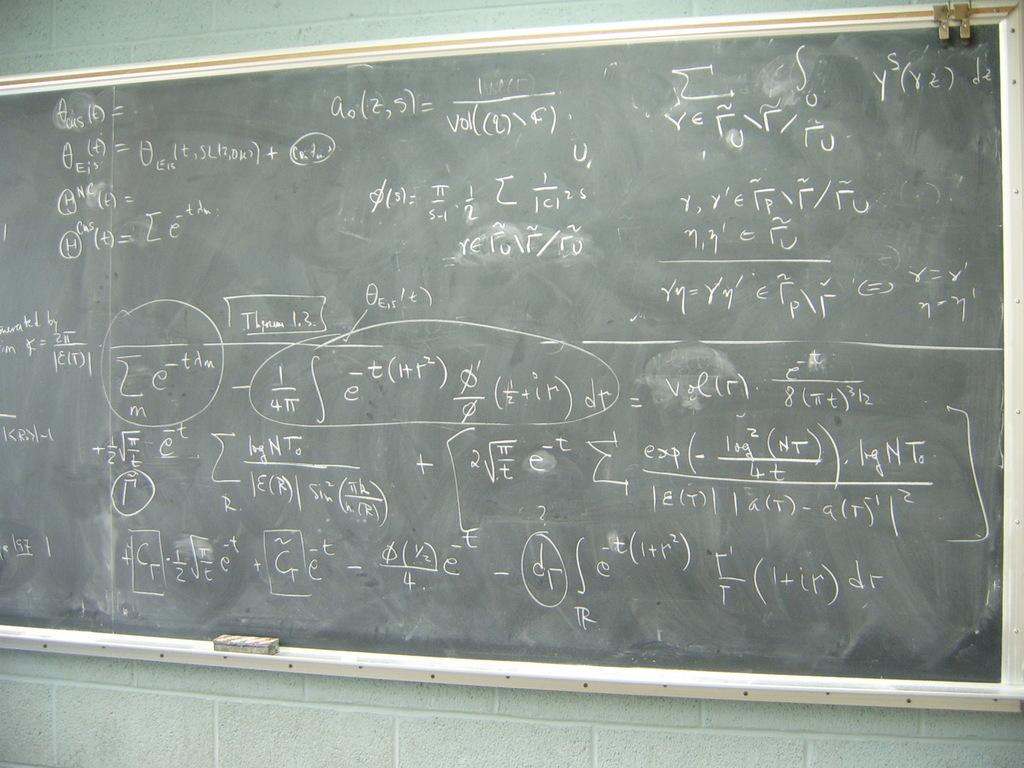<image>
Render a clear and concise summary of the photo. a chalkboard with dr written on the bottom right 